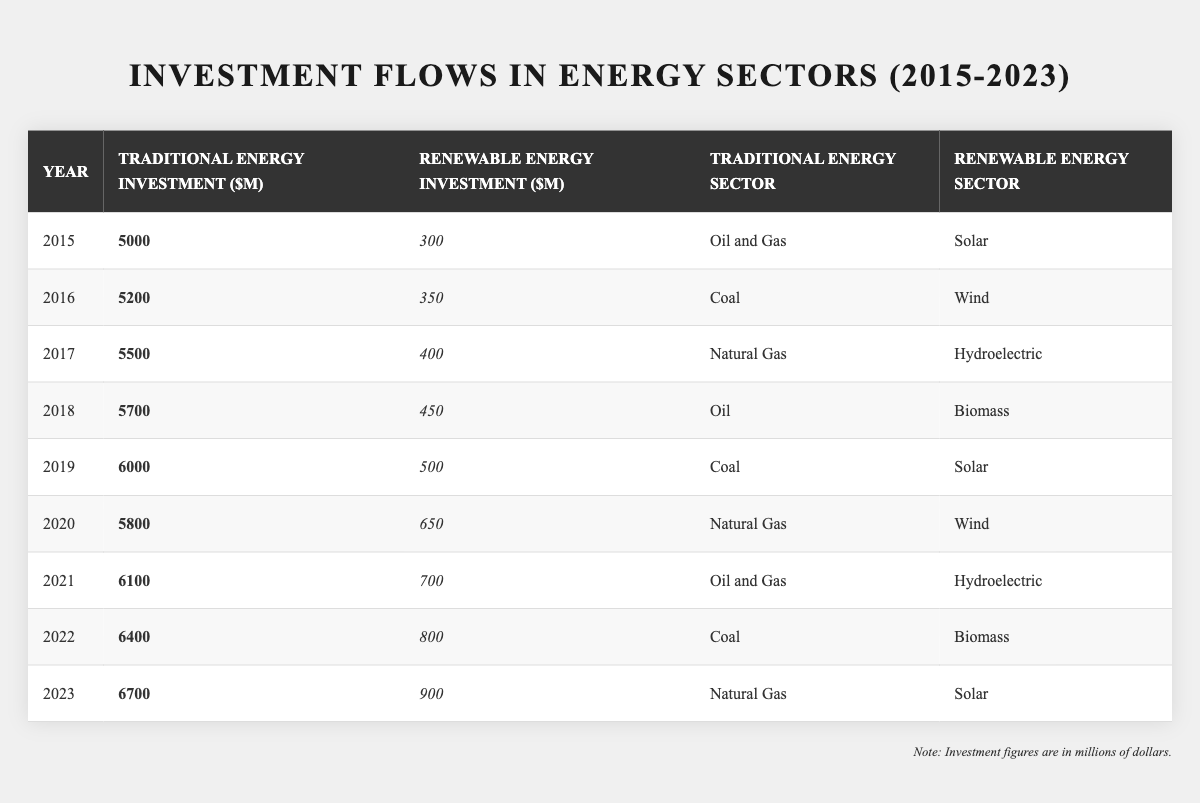What was the total traditional energy investment in 2015? The table shows that the traditional energy investment in 2015 was $5000 million.
Answer: 5000 Which renewable energy sector received the highest investment in 2020? According to the table, the renewable energy investment in 2020 was in Wind, amounting to $650 million, which is the highest for that year.
Answer: Wind What is the difference in traditional energy investment between 2023 and 2015? The traditional energy investment in 2023 is $6700 million and in 2015 it was $5000 million. The difference is $6700 - $5000 = $1700 million.
Answer: 1700 Did renewable energy investments consistently increase from 2015 to 2023? By examining the table, we see that renewable energy investments increased from $300 million in 2015 to $900 million in 2023, indicating a consistent increase.
Answer: Yes What was the average traditional energy investment from 2015 to 2023? First, we sum the traditional energy investments: 5000 + 5200 + 5500 + 5700 + 6000 + 5800 + 6100 + 6400 + 6700 = 50000. Then, we divide by the number of years, which is 9: 50000 / 9 ≈ 5555.56.
Answer: 5555.56 Which year had the least amount of renewable energy investment and how much was it? Upon reviewing the table, 2015 had the least renewable energy investment at $300 million.
Answer: 300 How much more was invested in traditional energy compared to renewable energy in 2022? In 2022, traditional energy investment was $6400 million and renewable was $800 million. The difference is $6400 - $800 = $5600 million more in traditional energy.
Answer: 5600 Which traditional energy sector had the highest investment in 2021? The table indicates that in 2021, the traditional energy investment was in Oil and Gas at $6100 million, which is the highest for that year.
Answer: Oil and Gas What was the total investment (both traditional and renewable) in 2019? In 2019, traditional energy investment was $6000 million and renewable energy investment was $500 million. The total investment is $6000 + $500 = $6500 million.
Answer: 6500 Was there ever a year when renewable energy investment surpassed traditional energy investment? The table shows that renewable energy investments never surpassed traditional energy investments in any of the years from 2015 to 2023.
Answer: No How does the investment trend in traditional energy compare to that in renewable energy over the years? By examining the table, traditional energy investments show a steady increase from $5000 million in 2015 to $6700 million in 2023, while renewable investments also increased from $300 million in 2015 to $900 million in 2023, but at a much slower rate relative to traditional energy.
Answer: Traditional energy grew faster 